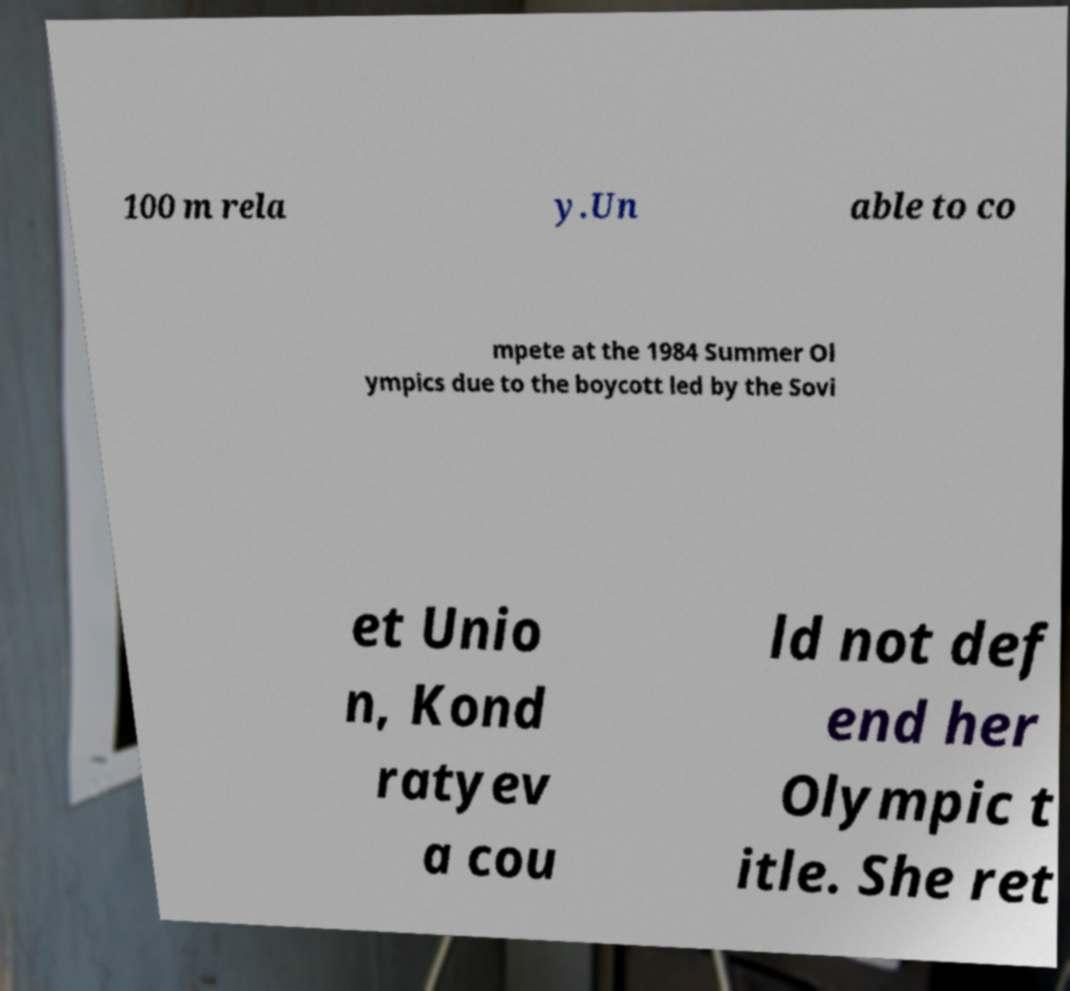Please read and relay the text visible in this image. What does it say? 100 m rela y.Un able to co mpete at the 1984 Summer Ol ympics due to the boycott led by the Sovi et Unio n, Kond ratyev a cou ld not def end her Olympic t itle. She ret 